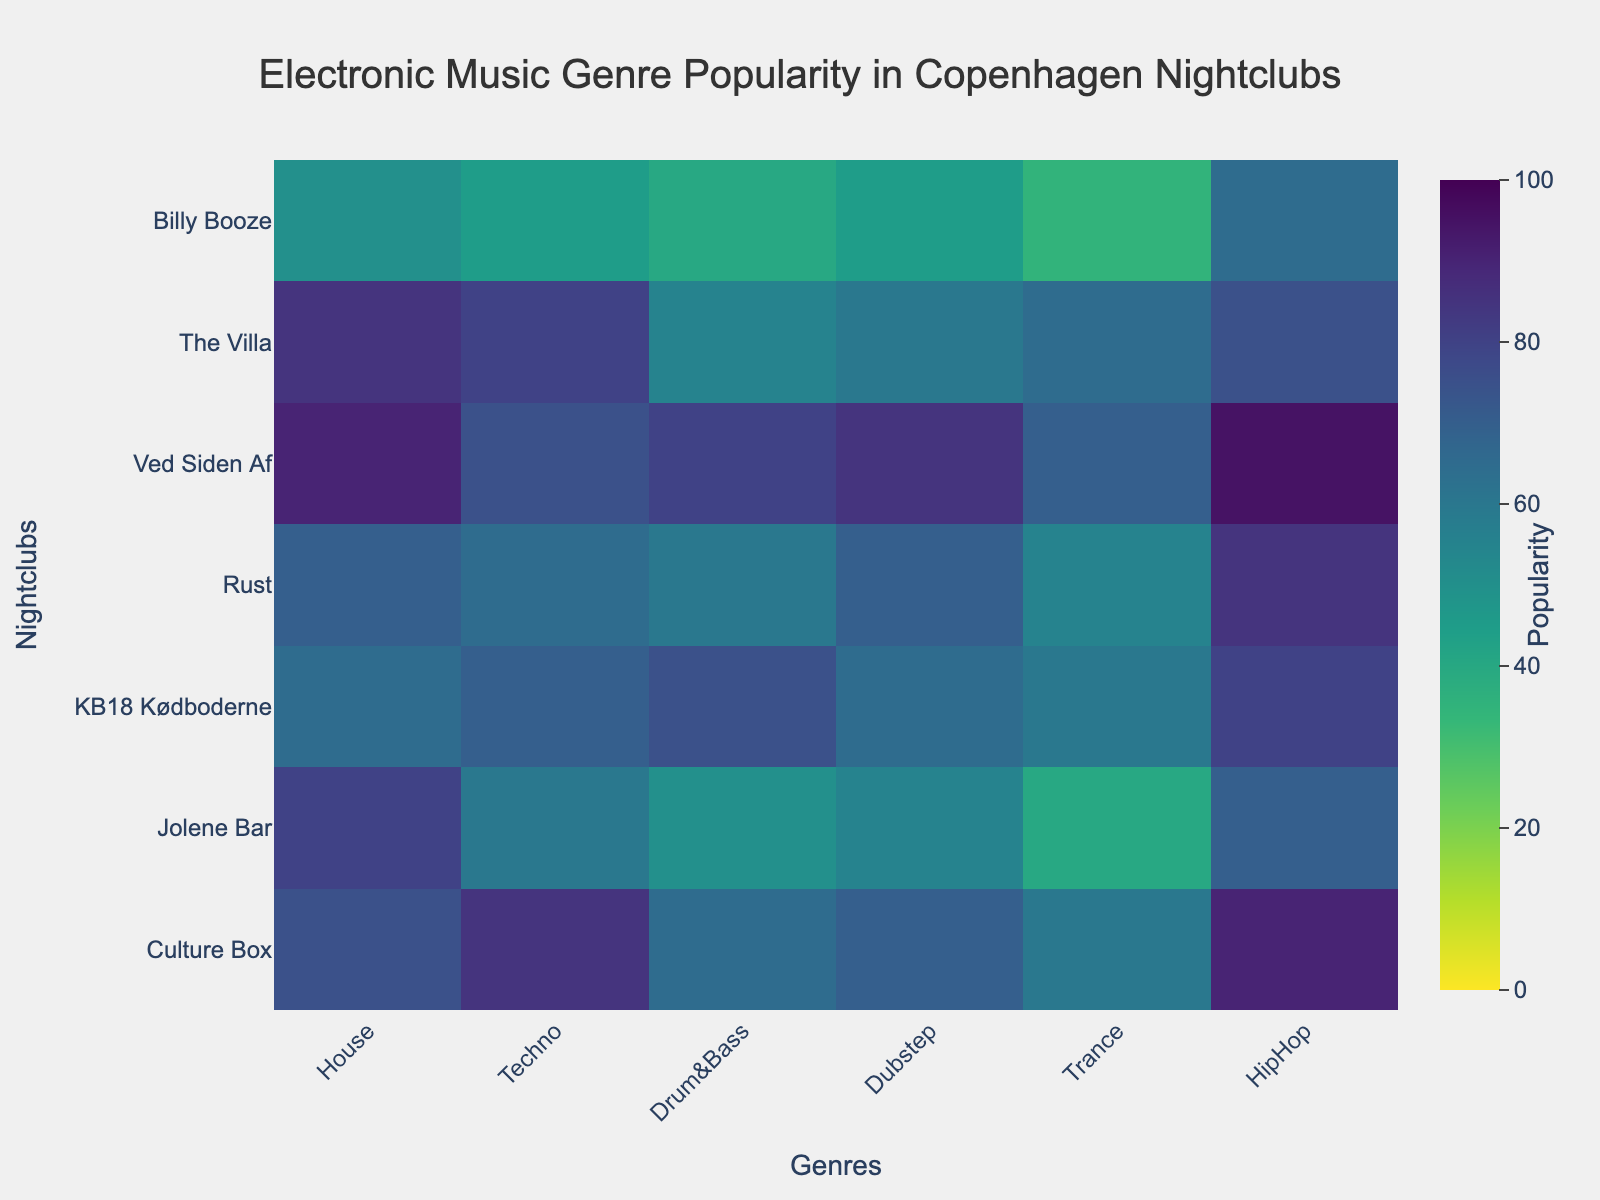Which genre is most popular in Culture Box? Look at the row for Culture Box and identify the highest value.
Answer: HipHop What's the average popularity of Dubstep across all nightclubs? Sum the popularity percentages of Dubstep across all nightclubs (70 + 55 + 65 + 70 + 85 + 60 + 45) and divide by the number of nightclubs (7).
Answer: 64.3 Which nightclub has the least popularity for House music? Check the House column for the lowest value and find the corresponding nightclub.
Answer: Billy Booze Is Trance more popular than Drum&Bass at Jolene Bar? Compare the values in the Trance and Drum&Bass columns for Jolene Bar.
Answer: No Which genre has the highest average popularity across all nightclubs? Sum the values for each genre and divide by the number of nightclubs, then compare these averages to find the highest one.
Answer: HipHop How does the popularity of Techno at The Villa compare to Ved Siden Af? Compare the Techno values for The Villa and Ved Siden Af.
Answer: Less Which nightclub has the most balanced popularity across different genres? (Consider it balanced if the differences among its genre values are small) Evaluate the range (max-min) of each nightclub's genre values and find the smallest range.
Answer: KB18 Kødboderne What's the difference in popularity of Drum&Bass and House at KB18 Kødboderne? Subtract the House value from the Drum&Bass value for KB18 Kødboderne.
Answer: 10 Based on the heatmap, which nightclubs have the highest and lowest overall popularity? Sum the popularity scores for all genres for each nightclub and compare these sums.
Answer: Ved Siden Af (highest), Billy Booze (lowest) Which nightclub shows a significant difference in popularity between electronic music genres and HipHop? Compare the values for electronic music genres (House, Techno, Drum&Bass, Dubstep, Trance) and HipHop for each nightclub and look for the largest discrepancies.
Answer: Jolene Bar 